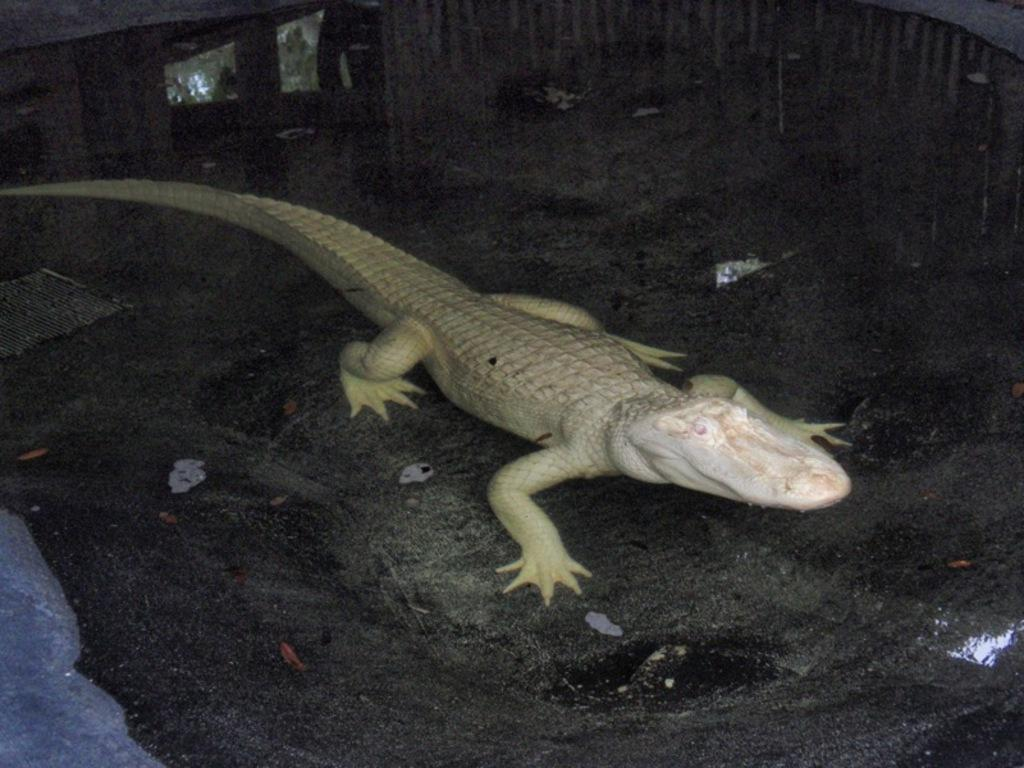What type of animal is in the image? There is a lizard in the image. Where is the lizard located in the image? The lizard is on the floor. What is the purpose of the baby in the image? There is no baby present in the image; it only features a lizard on the floor. 